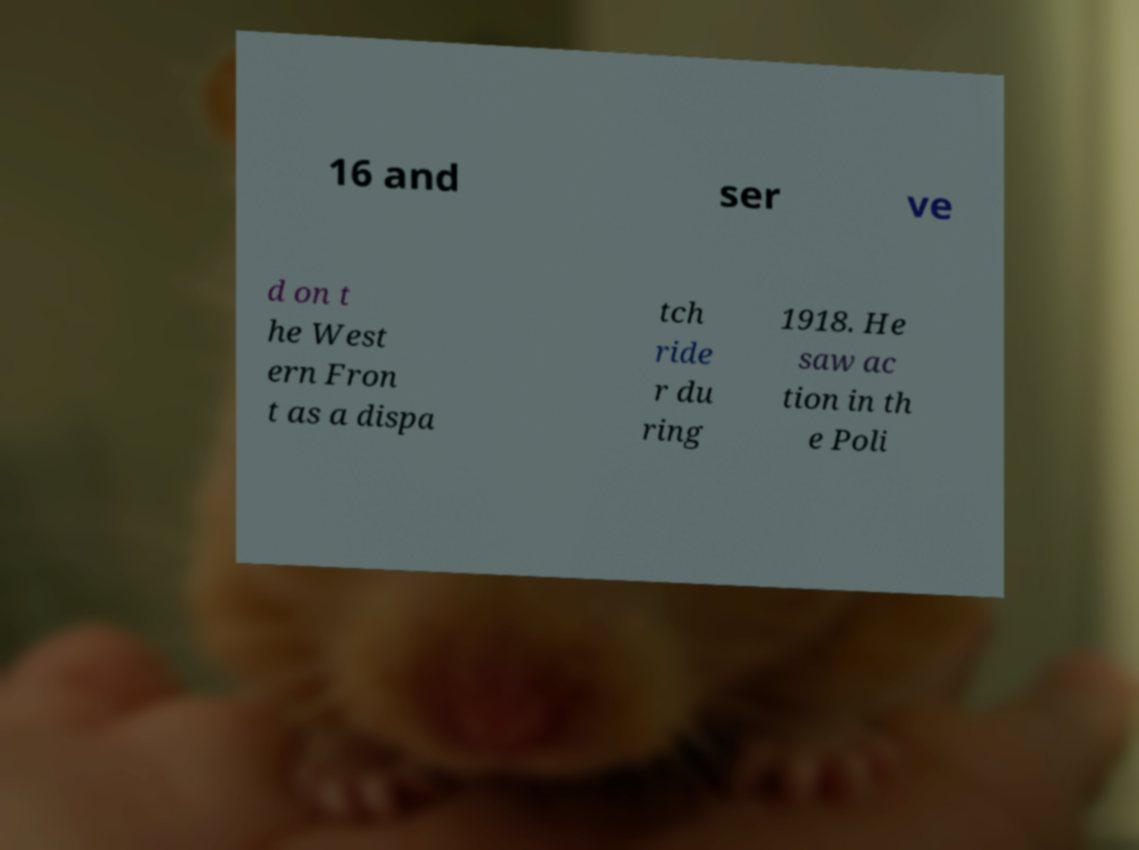Can you read and provide the text displayed in the image?This photo seems to have some interesting text. Can you extract and type it out for me? 16 and ser ve d on t he West ern Fron t as a dispa tch ride r du ring 1918. He saw ac tion in th e Poli 